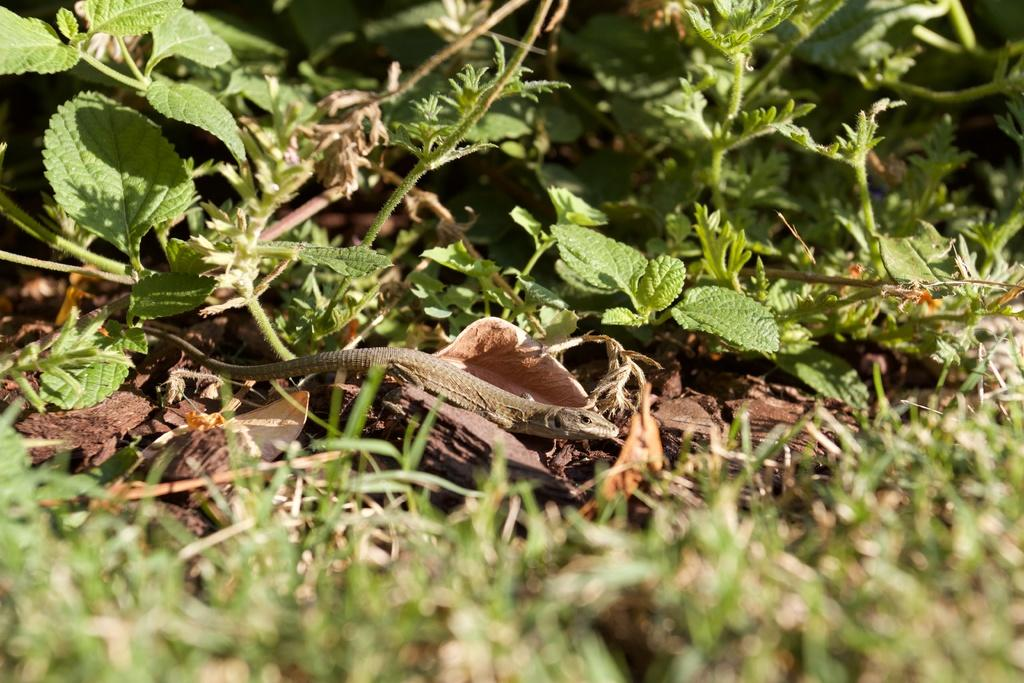What type of plants are in the image? There are small herbs in the image. What other living creature can be seen in the image? There is a lizard in the image. What type of porter is carrying the door in the image? There is no porter or door present in the image; it only features small herbs and a lizard. 